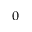<formula> <loc_0><loc_0><loc_500><loc_500>_ { 0 }</formula> 